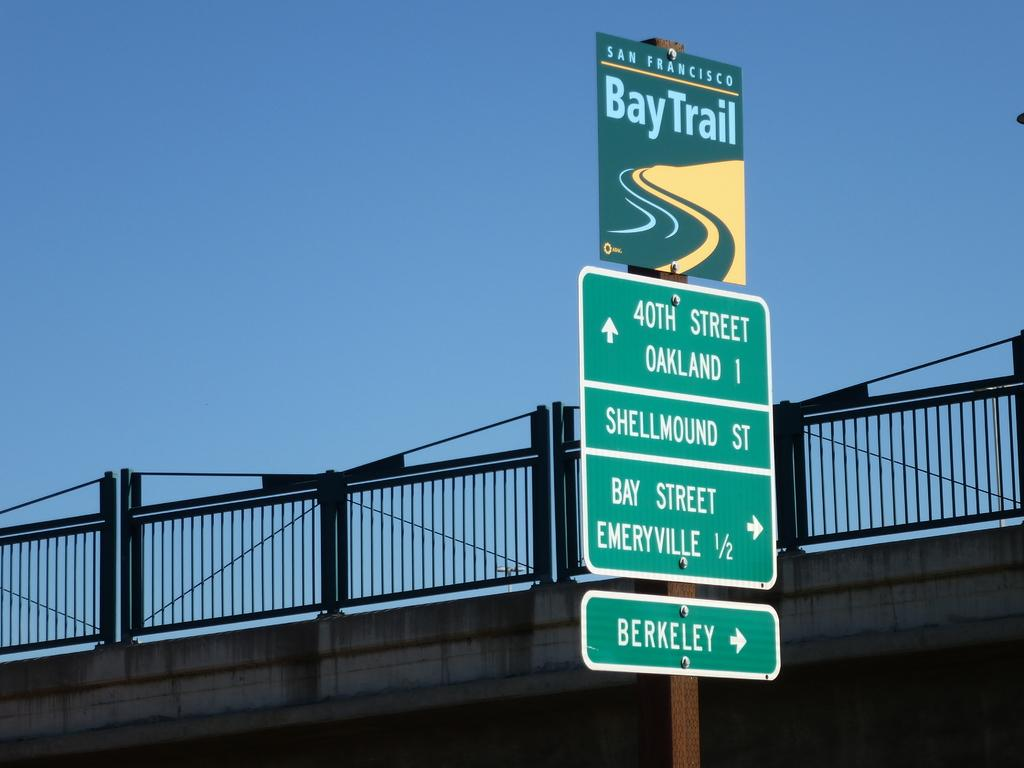<image>
Share a concise interpretation of the image provided. Along a city highway a tall sign reads different destination directions in an Francisco Bay Trail. 